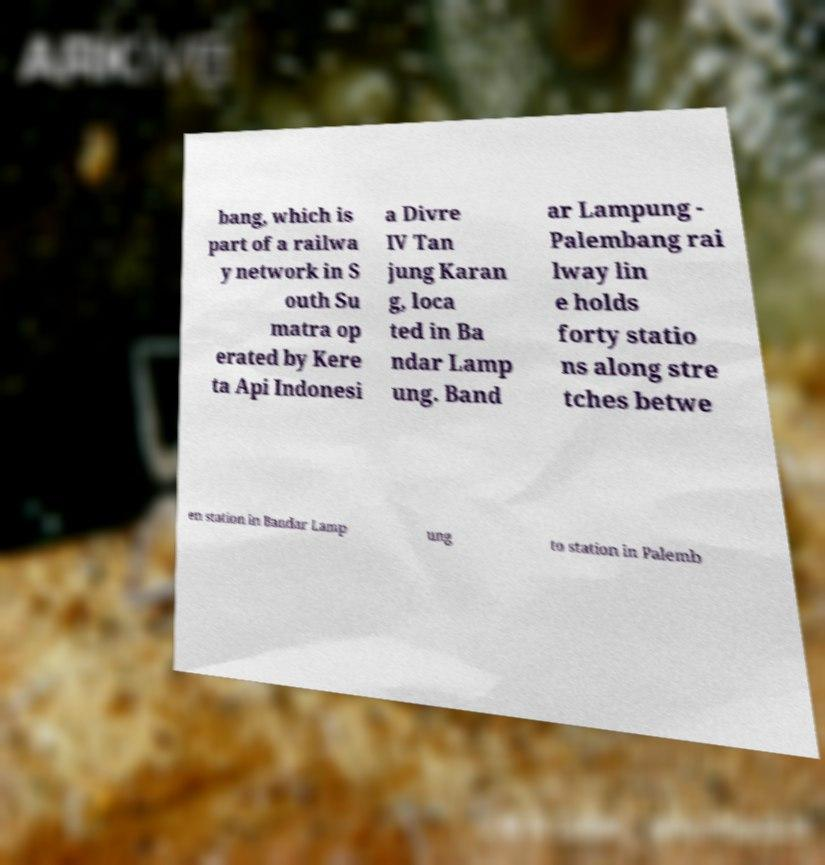I need the written content from this picture converted into text. Can you do that? bang, which is part of a railwa y network in S outh Su matra op erated by Kere ta Api Indonesi a Divre IV Tan jung Karan g, loca ted in Ba ndar Lamp ung. Band ar Lampung - Palembang rai lway lin e holds forty statio ns along stre tches betwe en station in Bandar Lamp ung to station in Palemb 